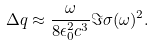Convert formula to latex. <formula><loc_0><loc_0><loc_500><loc_500>\Delta q \approx \frac { \omega } { 8 \epsilon _ { 0 } ^ { 2 } c ^ { 3 } } \Im \sigma ( \omega ) ^ { 2 } .</formula> 